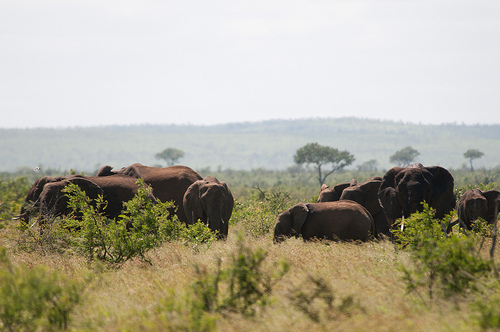What kind of birds can be seen in the scenery? In the distance, there appears to be storks or similar long-legged birds often found in savannah regions, known for their wading habits. 